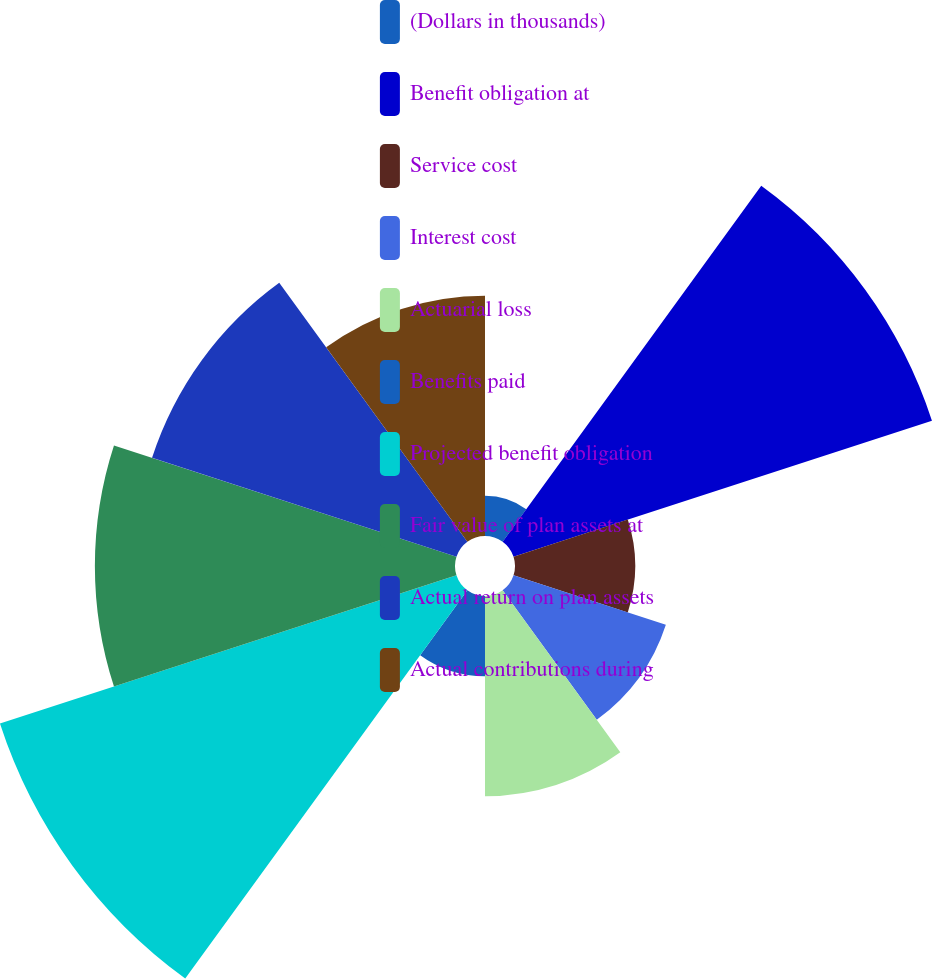Convert chart to OTSL. <chart><loc_0><loc_0><loc_500><loc_500><pie_chart><fcel>(Dollars in thousands)<fcel>Benefit obligation at<fcel>Service cost<fcel>Interest cost<fcel>Actuarial loss<fcel>Benefits paid<fcel>Projected benefit obligation<fcel>Fair value of plan assets at<fcel>Actual return on plan assets<fcel>Actual contributions during<nl><fcel>1.65%<fcel>18.02%<fcel>4.92%<fcel>6.56%<fcel>8.2%<fcel>3.29%<fcel>19.66%<fcel>14.75%<fcel>13.11%<fcel>9.84%<nl></chart> 